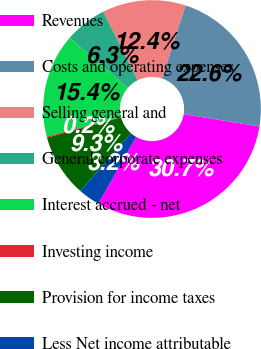Convert chart to OTSL. <chart><loc_0><loc_0><loc_500><loc_500><pie_chart><fcel>Revenues<fcel>Costs and operating expenses<fcel>Selling general and<fcel>General corporate expenses<fcel>Interest accrued - net<fcel>Investing income<fcel>Provision for income taxes<fcel>Less Net income attributable<nl><fcel>30.66%<fcel>22.58%<fcel>12.37%<fcel>6.27%<fcel>15.41%<fcel>0.17%<fcel>9.32%<fcel>3.22%<nl></chart> 